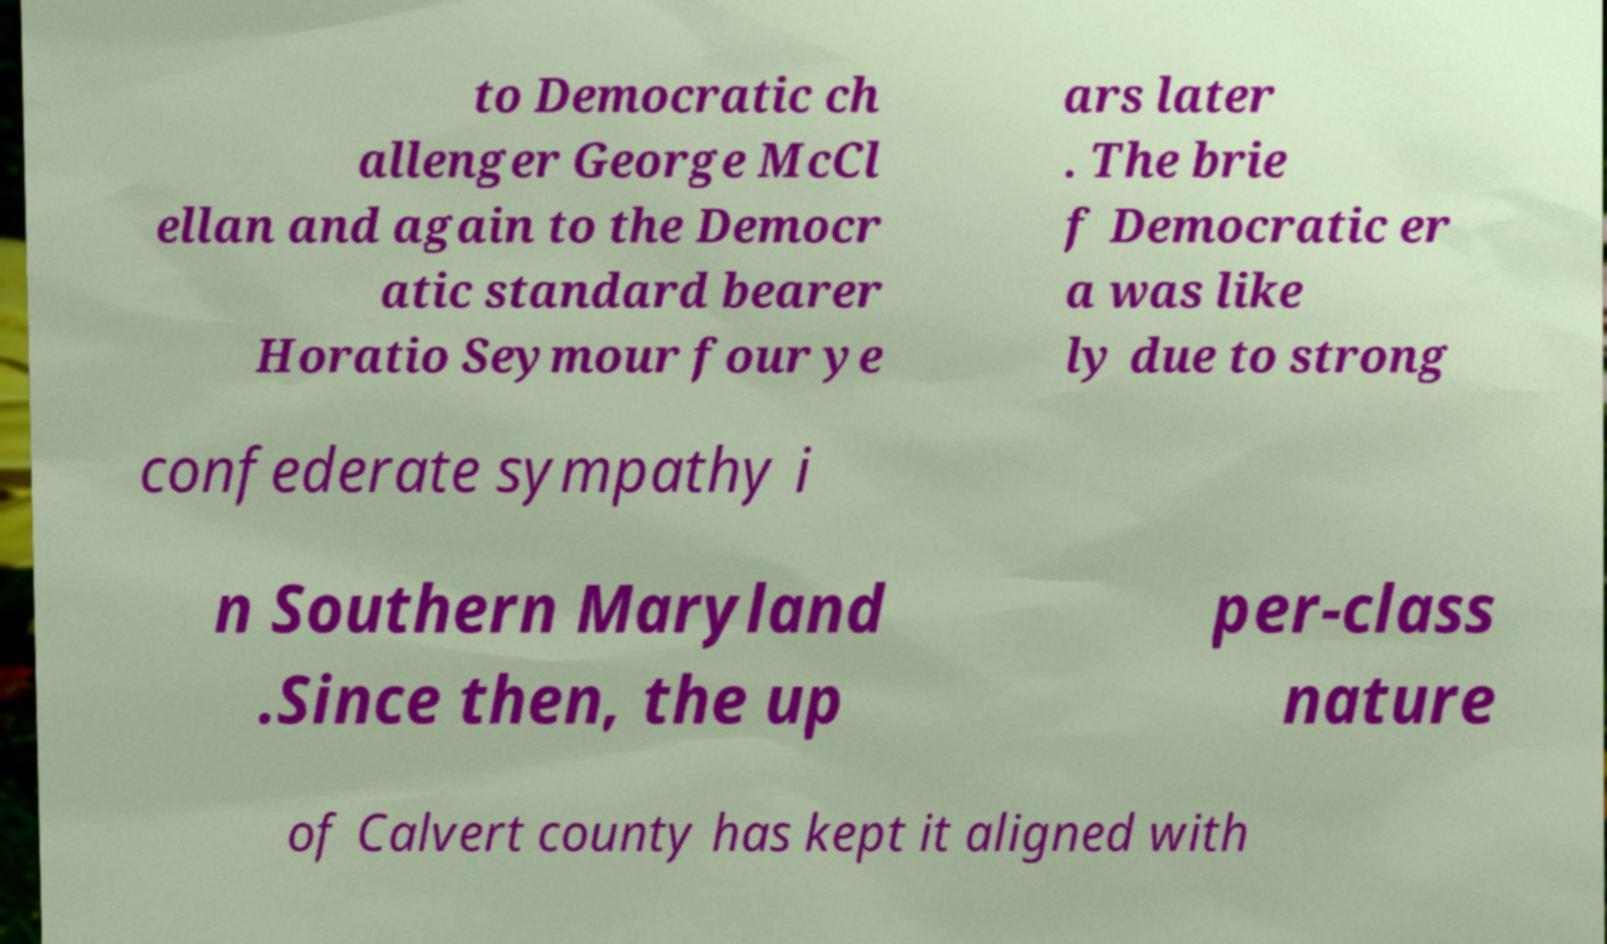There's text embedded in this image that I need extracted. Can you transcribe it verbatim? to Democratic ch allenger George McCl ellan and again to the Democr atic standard bearer Horatio Seymour four ye ars later . The brie f Democratic er a was like ly due to strong confederate sympathy i n Southern Maryland .Since then, the up per-class nature of Calvert county has kept it aligned with 